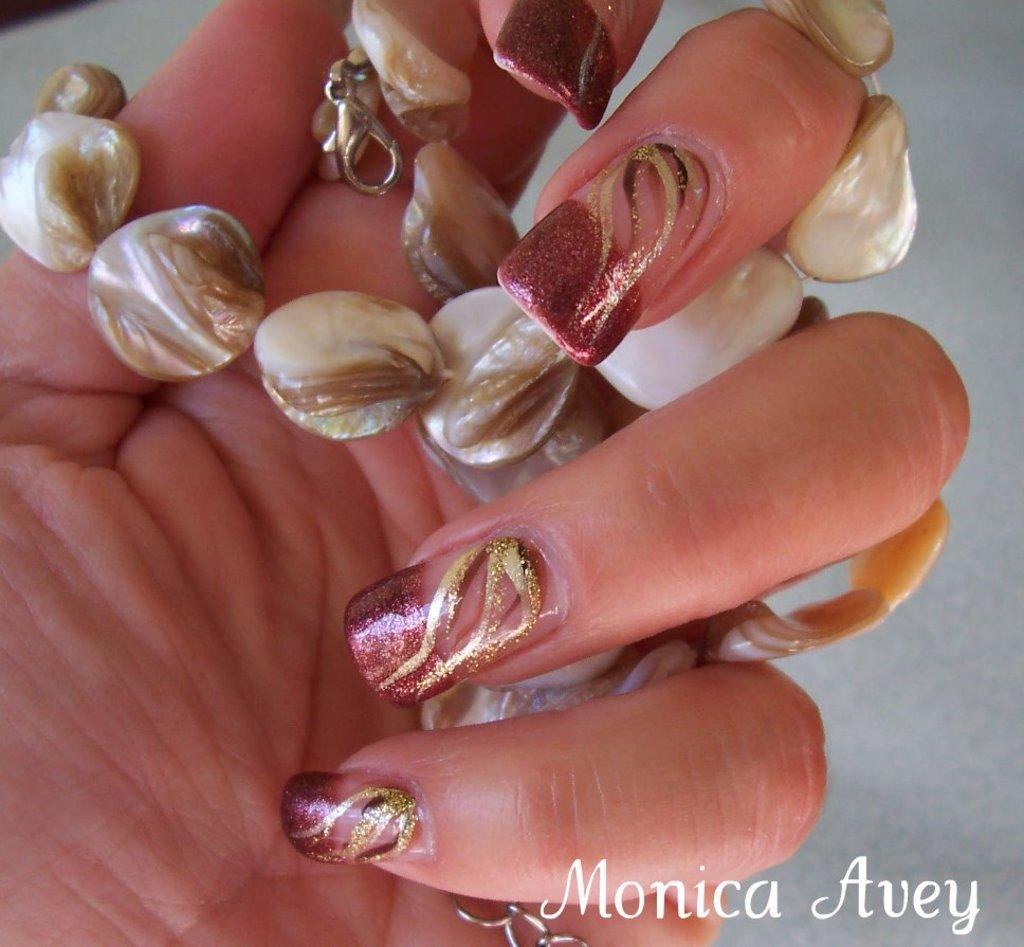Are these by monica?
Your answer should be very brief. Yes. Who sis these nails?
Your answer should be very brief. Monica avey. 